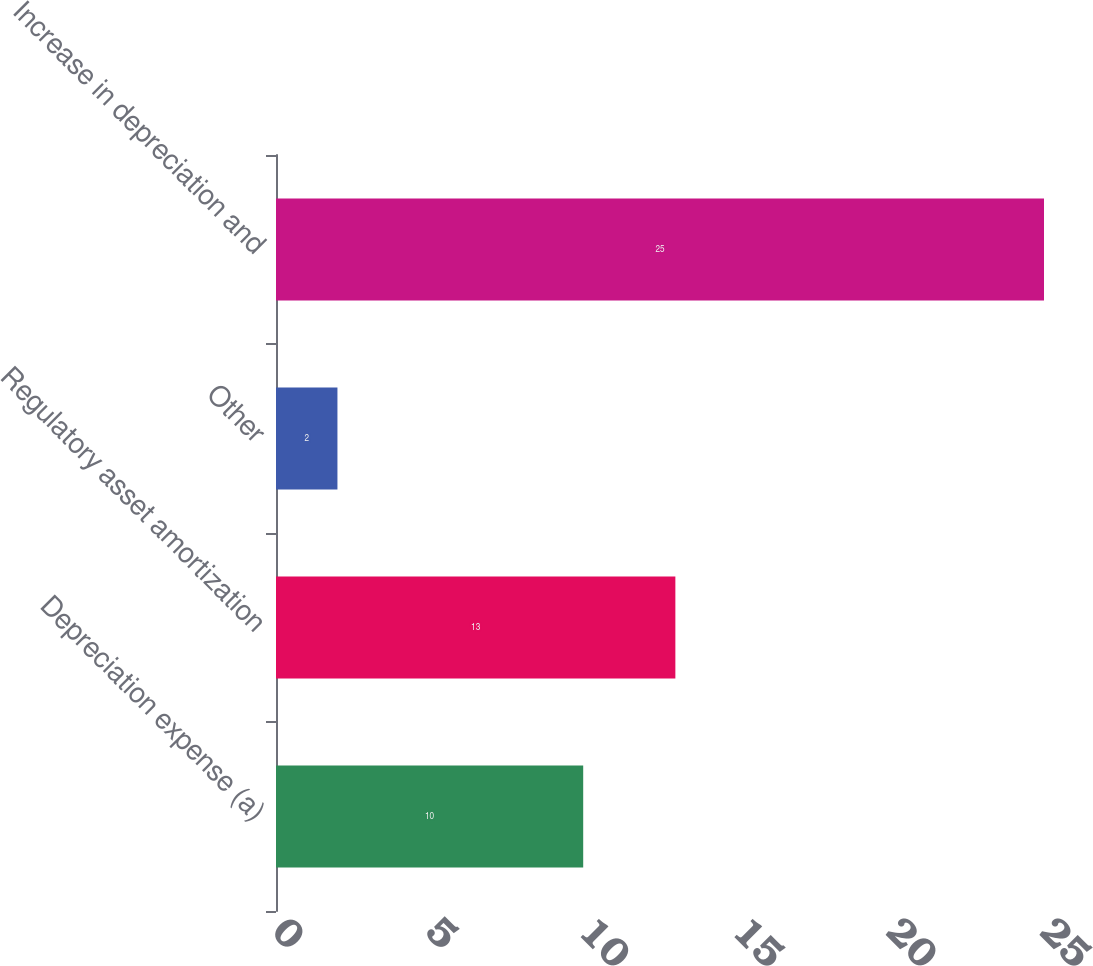Convert chart. <chart><loc_0><loc_0><loc_500><loc_500><bar_chart><fcel>Depreciation expense (a)<fcel>Regulatory asset amortization<fcel>Other<fcel>Increase in depreciation and<nl><fcel>10<fcel>13<fcel>2<fcel>25<nl></chart> 